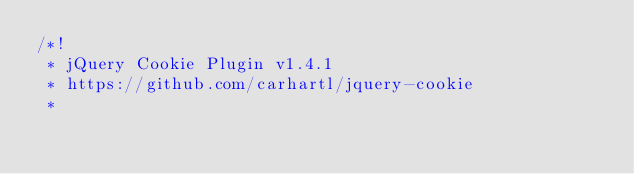Convert code to text. <code><loc_0><loc_0><loc_500><loc_500><_JavaScript_>/*!
 * jQuery Cookie Plugin v1.4.1
 * https://github.com/carhartl/jquery-cookie
 *</code> 